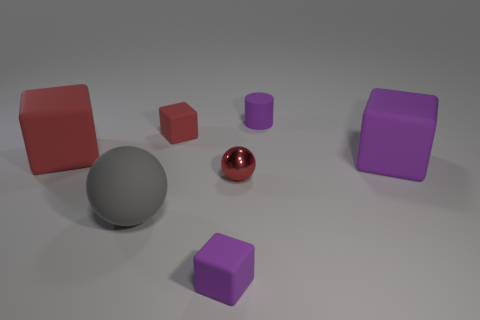Are there any other things that have the same material as the tiny sphere?
Your answer should be very brief. No. What material is the thing that is in front of the sphere to the left of the small red rubber thing behind the gray rubber sphere?
Make the answer very short. Rubber. There is another tiny thing that is the same color as the metallic object; what is it made of?
Offer a very short reply. Rubber. How many things are big purple things or tiny purple objects?
Give a very brief answer. 3. Is the purple thing that is in front of the big ball made of the same material as the small red sphere?
Your response must be concise. No. How many objects are either small purple rubber things that are in front of the big gray object or blocks?
Your answer should be very brief. 4. What is the color of the big ball that is the same material as the small red cube?
Offer a terse response. Gray. Are there any purple matte cylinders of the same size as the red ball?
Ensure brevity in your answer.  Yes. Does the large rubber block that is to the left of the big purple rubber object have the same color as the tiny shiny object?
Provide a short and direct response. Yes. What is the color of the tiny matte object that is behind the large gray object and left of the red metal ball?
Your answer should be compact. Red. 